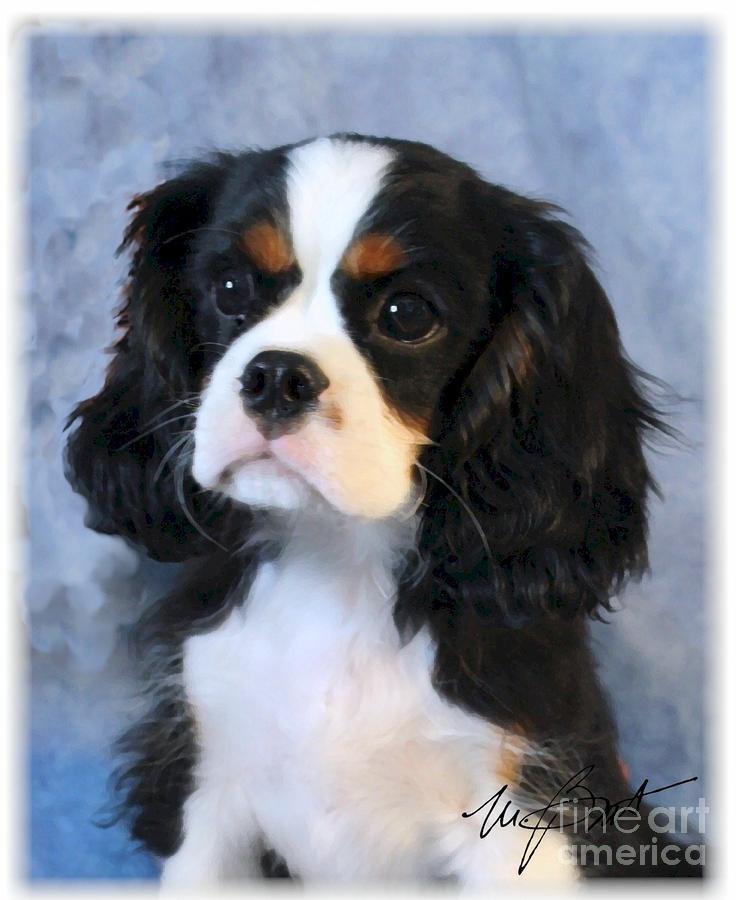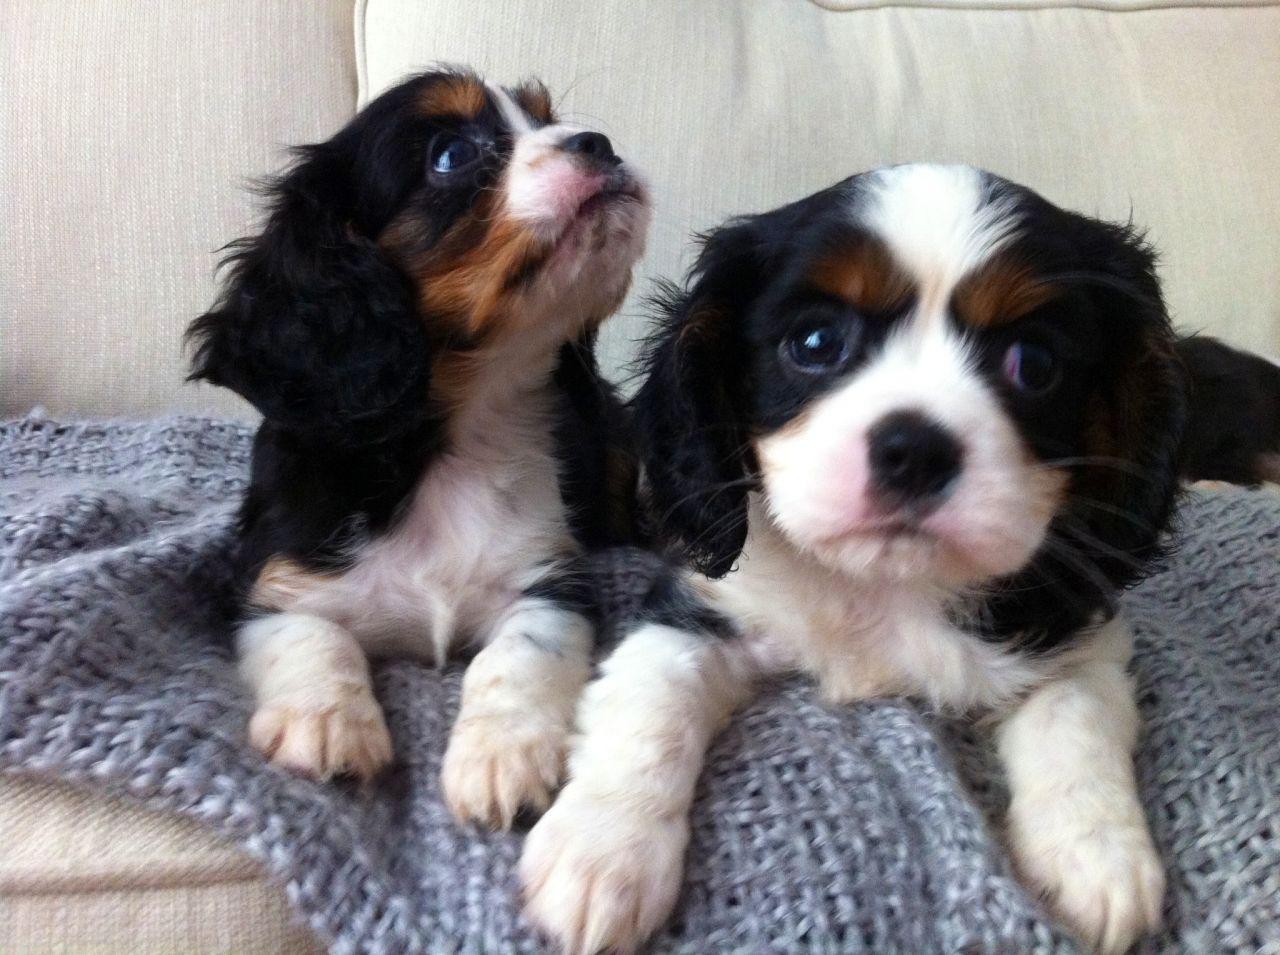The first image is the image on the left, the second image is the image on the right. For the images displayed, is the sentence "At least one image shows one or more Cavalier King Charles Spaniels sitting upright." factually correct? Answer yes or no. Yes. The first image is the image on the left, the second image is the image on the right. Examine the images to the left and right. Is the description "The image on the left contains twp dogs sitting next to each other." accurate? Answer yes or no. No. 